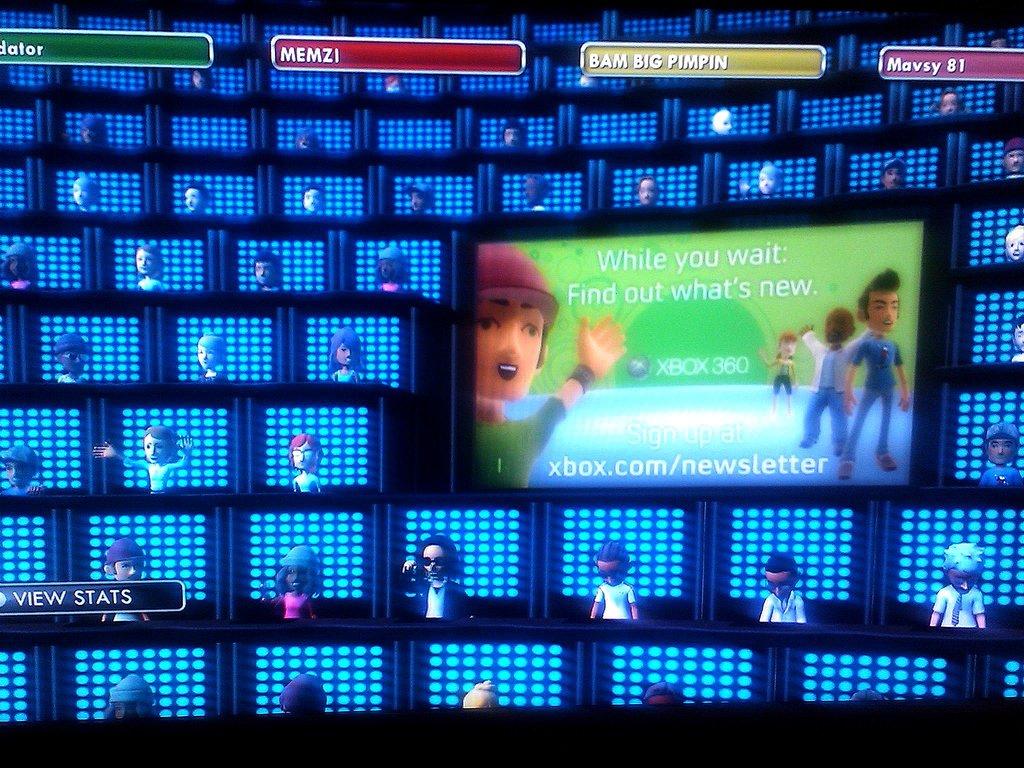What game company is being advertised?
Your answer should be compact. Xbox. What does the screen says?
Your answer should be very brief. While you wait find out what's new. 